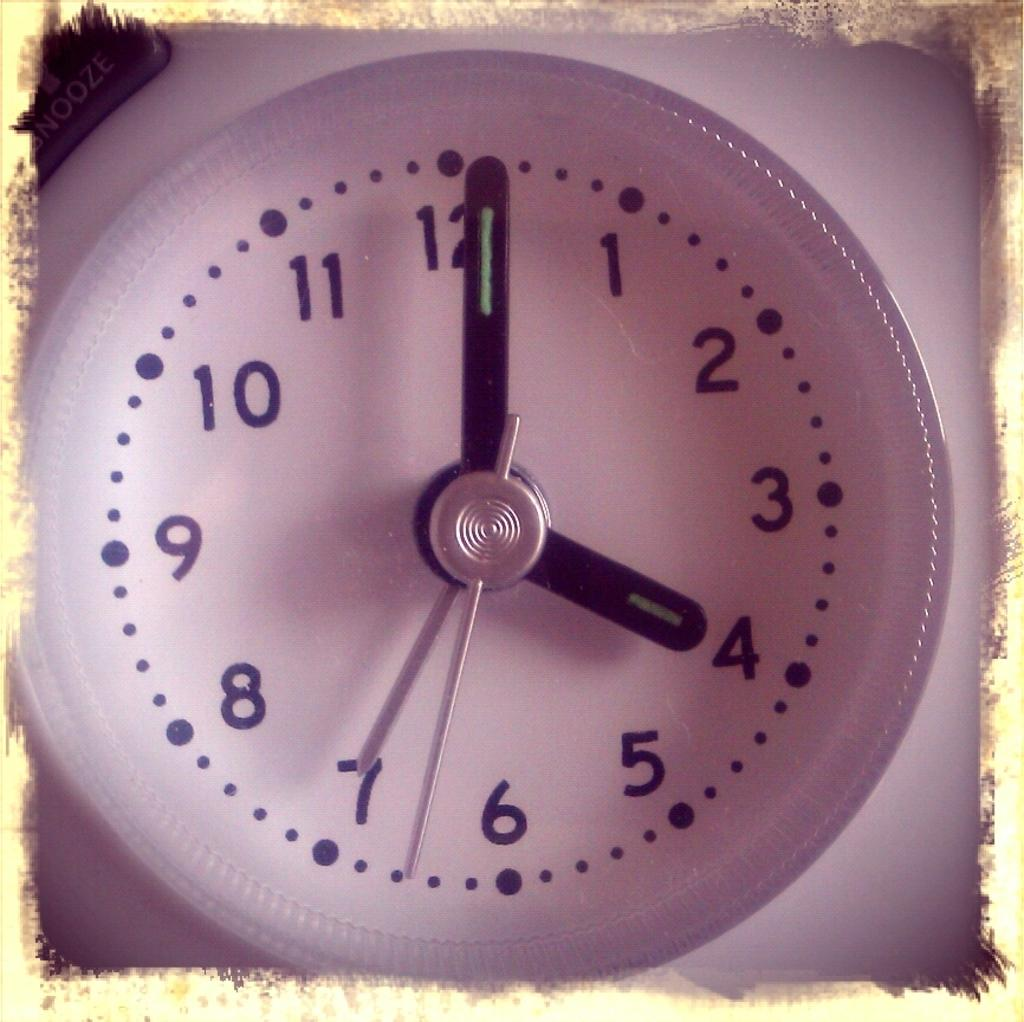What type of timekeeping device is present in the image? The image contains an analog clock. Can you describe the appearance of the clock? The clock has hands that indicate the time and a circular face with numbers. What grade does the comb receive in the image? There is no comb present in the image, and therefore no grade can be assigned. 